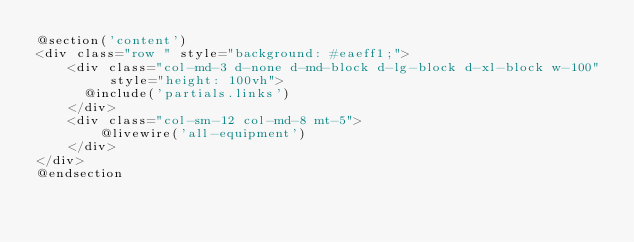Convert code to text. <code><loc_0><loc_0><loc_500><loc_500><_PHP_>@section('content')
<div class="row " style="background: #eaeff1;">
    <div class="col-md-3 d-none d-md-block d-lg-block d-xl-block w-100"  style="height: 100vh">
      @include('partials.links')
    </div>
    <div class="col-sm-12 col-md-8 mt-5">
        @livewire('all-equipment')
    </div>
</div>
@endsection</code> 